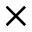Convert formula to latex. <formula><loc_0><loc_0><loc_500><loc_500>\times</formula> 